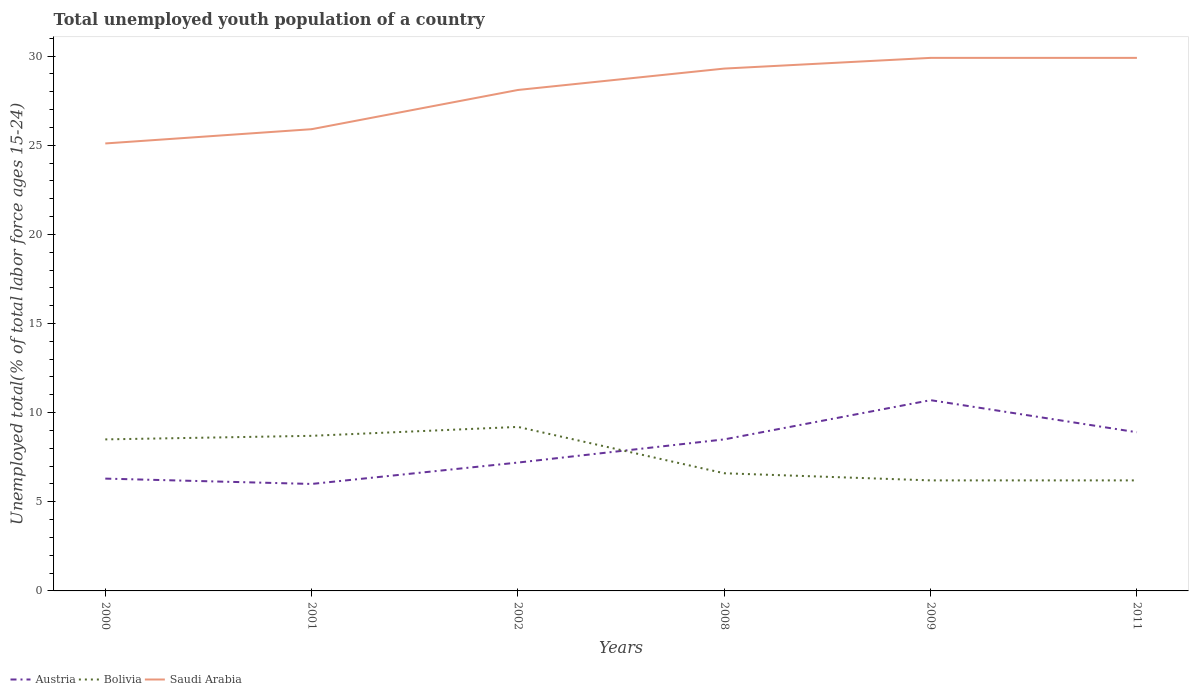Is the number of lines equal to the number of legend labels?
Your answer should be compact. Yes. What is the total percentage of total unemployed youth population of a country in Austria in the graph?
Your answer should be compact. -0.4. What is the difference between the highest and the second highest percentage of total unemployed youth population of a country in Bolivia?
Give a very brief answer. 3. Is the percentage of total unemployed youth population of a country in Bolivia strictly greater than the percentage of total unemployed youth population of a country in Austria over the years?
Provide a succinct answer. No. How many lines are there?
Offer a very short reply. 3. How many years are there in the graph?
Offer a very short reply. 6. What is the title of the graph?
Offer a terse response. Total unemployed youth population of a country. Does "Sao Tome and Principe" appear as one of the legend labels in the graph?
Your answer should be compact. No. What is the label or title of the Y-axis?
Offer a very short reply. Unemployed total(% of total labor force ages 15-24). What is the Unemployed total(% of total labor force ages 15-24) in Austria in 2000?
Offer a very short reply. 6.3. What is the Unemployed total(% of total labor force ages 15-24) of Saudi Arabia in 2000?
Give a very brief answer. 25.1. What is the Unemployed total(% of total labor force ages 15-24) of Austria in 2001?
Your answer should be very brief. 6. What is the Unemployed total(% of total labor force ages 15-24) of Bolivia in 2001?
Keep it short and to the point. 8.7. What is the Unemployed total(% of total labor force ages 15-24) in Saudi Arabia in 2001?
Make the answer very short. 25.9. What is the Unemployed total(% of total labor force ages 15-24) of Austria in 2002?
Keep it short and to the point. 7.2. What is the Unemployed total(% of total labor force ages 15-24) of Bolivia in 2002?
Make the answer very short. 9.2. What is the Unemployed total(% of total labor force ages 15-24) in Saudi Arabia in 2002?
Ensure brevity in your answer.  28.1. What is the Unemployed total(% of total labor force ages 15-24) in Bolivia in 2008?
Provide a short and direct response. 6.6. What is the Unemployed total(% of total labor force ages 15-24) of Saudi Arabia in 2008?
Ensure brevity in your answer.  29.3. What is the Unemployed total(% of total labor force ages 15-24) in Austria in 2009?
Your response must be concise. 10.7. What is the Unemployed total(% of total labor force ages 15-24) in Bolivia in 2009?
Provide a short and direct response. 6.2. What is the Unemployed total(% of total labor force ages 15-24) in Saudi Arabia in 2009?
Your answer should be compact. 29.9. What is the Unemployed total(% of total labor force ages 15-24) in Austria in 2011?
Offer a very short reply. 8.9. What is the Unemployed total(% of total labor force ages 15-24) of Bolivia in 2011?
Offer a very short reply. 6.2. What is the Unemployed total(% of total labor force ages 15-24) of Saudi Arabia in 2011?
Your answer should be compact. 29.9. Across all years, what is the maximum Unemployed total(% of total labor force ages 15-24) of Austria?
Make the answer very short. 10.7. Across all years, what is the maximum Unemployed total(% of total labor force ages 15-24) of Bolivia?
Your answer should be very brief. 9.2. Across all years, what is the maximum Unemployed total(% of total labor force ages 15-24) of Saudi Arabia?
Offer a terse response. 29.9. Across all years, what is the minimum Unemployed total(% of total labor force ages 15-24) of Austria?
Provide a succinct answer. 6. Across all years, what is the minimum Unemployed total(% of total labor force ages 15-24) in Bolivia?
Provide a succinct answer. 6.2. Across all years, what is the minimum Unemployed total(% of total labor force ages 15-24) of Saudi Arabia?
Your answer should be very brief. 25.1. What is the total Unemployed total(% of total labor force ages 15-24) of Austria in the graph?
Provide a short and direct response. 47.6. What is the total Unemployed total(% of total labor force ages 15-24) of Bolivia in the graph?
Offer a very short reply. 45.4. What is the total Unemployed total(% of total labor force ages 15-24) of Saudi Arabia in the graph?
Your answer should be very brief. 168.2. What is the difference between the Unemployed total(% of total labor force ages 15-24) in Austria in 2000 and that in 2001?
Keep it short and to the point. 0.3. What is the difference between the Unemployed total(% of total labor force ages 15-24) of Saudi Arabia in 2000 and that in 2001?
Provide a succinct answer. -0.8. What is the difference between the Unemployed total(% of total labor force ages 15-24) of Bolivia in 2000 and that in 2002?
Offer a terse response. -0.7. What is the difference between the Unemployed total(% of total labor force ages 15-24) of Austria in 2000 and that in 2008?
Your response must be concise. -2.2. What is the difference between the Unemployed total(% of total labor force ages 15-24) of Bolivia in 2000 and that in 2009?
Your response must be concise. 2.3. What is the difference between the Unemployed total(% of total labor force ages 15-24) in Austria in 2000 and that in 2011?
Provide a short and direct response. -2.6. What is the difference between the Unemployed total(% of total labor force ages 15-24) of Bolivia in 2000 and that in 2011?
Provide a short and direct response. 2.3. What is the difference between the Unemployed total(% of total labor force ages 15-24) in Bolivia in 2001 and that in 2002?
Offer a terse response. -0.5. What is the difference between the Unemployed total(% of total labor force ages 15-24) in Saudi Arabia in 2001 and that in 2002?
Offer a terse response. -2.2. What is the difference between the Unemployed total(% of total labor force ages 15-24) in Austria in 2001 and that in 2009?
Make the answer very short. -4.7. What is the difference between the Unemployed total(% of total labor force ages 15-24) of Bolivia in 2001 and that in 2009?
Offer a terse response. 2.5. What is the difference between the Unemployed total(% of total labor force ages 15-24) in Bolivia in 2001 and that in 2011?
Provide a short and direct response. 2.5. What is the difference between the Unemployed total(% of total labor force ages 15-24) of Saudi Arabia in 2001 and that in 2011?
Provide a succinct answer. -4. What is the difference between the Unemployed total(% of total labor force ages 15-24) of Austria in 2002 and that in 2008?
Provide a short and direct response. -1.3. What is the difference between the Unemployed total(% of total labor force ages 15-24) in Bolivia in 2002 and that in 2008?
Provide a succinct answer. 2.6. What is the difference between the Unemployed total(% of total labor force ages 15-24) in Austria in 2002 and that in 2009?
Ensure brevity in your answer.  -3.5. What is the difference between the Unemployed total(% of total labor force ages 15-24) in Saudi Arabia in 2002 and that in 2009?
Your answer should be very brief. -1.8. What is the difference between the Unemployed total(% of total labor force ages 15-24) of Austria in 2002 and that in 2011?
Give a very brief answer. -1.7. What is the difference between the Unemployed total(% of total labor force ages 15-24) in Austria in 2008 and that in 2009?
Offer a terse response. -2.2. What is the difference between the Unemployed total(% of total labor force ages 15-24) in Austria in 2008 and that in 2011?
Your response must be concise. -0.4. What is the difference between the Unemployed total(% of total labor force ages 15-24) in Saudi Arabia in 2008 and that in 2011?
Offer a very short reply. -0.6. What is the difference between the Unemployed total(% of total labor force ages 15-24) in Austria in 2009 and that in 2011?
Offer a very short reply. 1.8. What is the difference between the Unemployed total(% of total labor force ages 15-24) of Austria in 2000 and the Unemployed total(% of total labor force ages 15-24) of Saudi Arabia in 2001?
Offer a very short reply. -19.6. What is the difference between the Unemployed total(% of total labor force ages 15-24) of Bolivia in 2000 and the Unemployed total(% of total labor force ages 15-24) of Saudi Arabia in 2001?
Make the answer very short. -17.4. What is the difference between the Unemployed total(% of total labor force ages 15-24) of Austria in 2000 and the Unemployed total(% of total labor force ages 15-24) of Bolivia in 2002?
Ensure brevity in your answer.  -2.9. What is the difference between the Unemployed total(% of total labor force ages 15-24) in Austria in 2000 and the Unemployed total(% of total labor force ages 15-24) in Saudi Arabia in 2002?
Your answer should be compact. -21.8. What is the difference between the Unemployed total(% of total labor force ages 15-24) of Bolivia in 2000 and the Unemployed total(% of total labor force ages 15-24) of Saudi Arabia in 2002?
Provide a short and direct response. -19.6. What is the difference between the Unemployed total(% of total labor force ages 15-24) of Austria in 2000 and the Unemployed total(% of total labor force ages 15-24) of Saudi Arabia in 2008?
Offer a very short reply. -23. What is the difference between the Unemployed total(% of total labor force ages 15-24) of Bolivia in 2000 and the Unemployed total(% of total labor force ages 15-24) of Saudi Arabia in 2008?
Your answer should be compact. -20.8. What is the difference between the Unemployed total(% of total labor force ages 15-24) in Austria in 2000 and the Unemployed total(% of total labor force ages 15-24) in Saudi Arabia in 2009?
Your answer should be compact. -23.6. What is the difference between the Unemployed total(% of total labor force ages 15-24) of Bolivia in 2000 and the Unemployed total(% of total labor force ages 15-24) of Saudi Arabia in 2009?
Give a very brief answer. -21.4. What is the difference between the Unemployed total(% of total labor force ages 15-24) in Austria in 2000 and the Unemployed total(% of total labor force ages 15-24) in Bolivia in 2011?
Make the answer very short. 0.1. What is the difference between the Unemployed total(% of total labor force ages 15-24) in Austria in 2000 and the Unemployed total(% of total labor force ages 15-24) in Saudi Arabia in 2011?
Your response must be concise. -23.6. What is the difference between the Unemployed total(% of total labor force ages 15-24) in Bolivia in 2000 and the Unemployed total(% of total labor force ages 15-24) in Saudi Arabia in 2011?
Ensure brevity in your answer.  -21.4. What is the difference between the Unemployed total(% of total labor force ages 15-24) in Austria in 2001 and the Unemployed total(% of total labor force ages 15-24) in Saudi Arabia in 2002?
Ensure brevity in your answer.  -22.1. What is the difference between the Unemployed total(% of total labor force ages 15-24) of Bolivia in 2001 and the Unemployed total(% of total labor force ages 15-24) of Saudi Arabia in 2002?
Keep it short and to the point. -19.4. What is the difference between the Unemployed total(% of total labor force ages 15-24) of Austria in 2001 and the Unemployed total(% of total labor force ages 15-24) of Saudi Arabia in 2008?
Ensure brevity in your answer.  -23.3. What is the difference between the Unemployed total(% of total labor force ages 15-24) in Bolivia in 2001 and the Unemployed total(% of total labor force ages 15-24) in Saudi Arabia in 2008?
Your answer should be compact. -20.6. What is the difference between the Unemployed total(% of total labor force ages 15-24) of Austria in 2001 and the Unemployed total(% of total labor force ages 15-24) of Bolivia in 2009?
Give a very brief answer. -0.2. What is the difference between the Unemployed total(% of total labor force ages 15-24) of Austria in 2001 and the Unemployed total(% of total labor force ages 15-24) of Saudi Arabia in 2009?
Give a very brief answer. -23.9. What is the difference between the Unemployed total(% of total labor force ages 15-24) of Bolivia in 2001 and the Unemployed total(% of total labor force ages 15-24) of Saudi Arabia in 2009?
Keep it short and to the point. -21.2. What is the difference between the Unemployed total(% of total labor force ages 15-24) of Austria in 2001 and the Unemployed total(% of total labor force ages 15-24) of Bolivia in 2011?
Keep it short and to the point. -0.2. What is the difference between the Unemployed total(% of total labor force ages 15-24) of Austria in 2001 and the Unemployed total(% of total labor force ages 15-24) of Saudi Arabia in 2011?
Provide a short and direct response. -23.9. What is the difference between the Unemployed total(% of total labor force ages 15-24) in Bolivia in 2001 and the Unemployed total(% of total labor force ages 15-24) in Saudi Arabia in 2011?
Make the answer very short. -21.2. What is the difference between the Unemployed total(% of total labor force ages 15-24) of Austria in 2002 and the Unemployed total(% of total labor force ages 15-24) of Bolivia in 2008?
Give a very brief answer. 0.6. What is the difference between the Unemployed total(% of total labor force ages 15-24) of Austria in 2002 and the Unemployed total(% of total labor force ages 15-24) of Saudi Arabia in 2008?
Keep it short and to the point. -22.1. What is the difference between the Unemployed total(% of total labor force ages 15-24) of Bolivia in 2002 and the Unemployed total(% of total labor force ages 15-24) of Saudi Arabia in 2008?
Offer a very short reply. -20.1. What is the difference between the Unemployed total(% of total labor force ages 15-24) of Austria in 2002 and the Unemployed total(% of total labor force ages 15-24) of Bolivia in 2009?
Keep it short and to the point. 1. What is the difference between the Unemployed total(% of total labor force ages 15-24) of Austria in 2002 and the Unemployed total(% of total labor force ages 15-24) of Saudi Arabia in 2009?
Offer a very short reply. -22.7. What is the difference between the Unemployed total(% of total labor force ages 15-24) of Bolivia in 2002 and the Unemployed total(% of total labor force ages 15-24) of Saudi Arabia in 2009?
Make the answer very short. -20.7. What is the difference between the Unemployed total(% of total labor force ages 15-24) of Austria in 2002 and the Unemployed total(% of total labor force ages 15-24) of Saudi Arabia in 2011?
Your answer should be very brief. -22.7. What is the difference between the Unemployed total(% of total labor force ages 15-24) of Bolivia in 2002 and the Unemployed total(% of total labor force ages 15-24) of Saudi Arabia in 2011?
Ensure brevity in your answer.  -20.7. What is the difference between the Unemployed total(% of total labor force ages 15-24) of Austria in 2008 and the Unemployed total(% of total labor force ages 15-24) of Saudi Arabia in 2009?
Give a very brief answer. -21.4. What is the difference between the Unemployed total(% of total labor force ages 15-24) in Bolivia in 2008 and the Unemployed total(% of total labor force ages 15-24) in Saudi Arabia in 2009?
Offer a very short reply. -23.3. What is the difference between the Unemployed total(% of total labor force ages 15-24) of Austria in 2008 and the Unemployed total(% of total labor force ages 15-24) of Saudi Arabia in 2011?
Your response must be concise. -21.4. What is the difference between the Unemployed total(% of total labor force ages 15-24) in Bolivia in 2008 and the Unemployed total(% of total labor force ages 15-24) in Saudi Arabia in 2011?
Provide a short and direct response. -23.3. What is the difference between the Unemployed total(% of total labor force ages 15-24) in Austria in 2009 and the Unemployed total(% of total labor force ages 15-24) in Bolivia in 2011?
Your response must be concise. 4.5. What is the difference between the Unemployed total(% of total labor force ages 15-24) in Austria in 2009 and the Unemployed total(% of total labor force ages 15-24) in Saudi Arabia in 2011?
Your answer should be very brief. -19.2. What is the difference between the Unemployed total(% of total labor force ages 15-24) in Bolivia in 2009 and the Unemployed total(% of total labor force ages 15-24) in Saudi Arabia in 2011?
Offer a terse response. -23.7. What is the average Unemployed total(% of total labor force ages 15-24) in Austria per year?
Your answer should be compact. 7.93. What is the average Unemployed total(% of total labor force ages 15-24) in Bolivia per year?
Give a very brief answer. 7.57. What is the average Unemployed total(% of total labor force ages 15-24) in Saudi Arabia per year?
Provide a succinct answer. 28.03. In the year 2000, what is the difference between the Unemployed total(% of total labor force ages 15-24) of Austria and Unemployed total(% of total labor force ages 15-24) of Saudi Arabia?
Keep it short and to the point. -18.8. In the year 2000, what is the difference between the Unemployed total(% of total labor force ages 15-24) of Bolivia and Unemployed total(% of total labor force ages 15-24) of Saudi Arabia?
Give a very brief answer. -16.6. In the year 2001, what is the difference between the Unemployed total(% of total labor force ages 15-24) in Austria and Unemployed total(% of total labor force ages 15-24) in Bolivia?
Offer a very short reply. -2.7. In the year 2001, what is the difference between the Unemployed total(% of total labor force ages 15-24) of Austria and Unemployed total(% of total labor force ages 15-24) of Saudi Arabia?
Your answer should be very brief. -19.9. In the year 2001, what is the difference between the Unemployed total(% of total labor force ages 15-24) in Bolivia and Unemployed total(% of total labor force ages 15-24) in Saudi Arabia?
Make the answer very short. -17.2. In the year 2002, what is the difference between the Unemployed total(% of total labor force ages 15-24) of Austria and Unemployed total(% of total labor force ages 15-24) of Saudi Arabia?
Your response must be concise. -20.9. In the year 2002, what is the difference between the Unemployed total(% of total labor force ages 15-24) in Bolivia and Unemployed total(% of total labor force ages 15-24) in Saudi Arabia?
Offer a terse response. -18.9. In the year 2008, what is the difference between the Unemployed total(% of total labor force ages 15-24) in Austria and Unemployed total(% of total labor force ages 15-24) in Bolivia?
Provide a short and direct response. 1.9. In the year 2008, what is the difference between the Unemployed total(% of total labor force ages 15-24) of Austria and Unemployed total(% of total labor force ages 15-24) of Saudi Arabia?
Ensure brevity in your answer.  -20.8. In the year 2008, what is the difference between the Unemployed total(% of total labor force ages 15-24) of Bolivia and Unemployed total(% of total labor force ages 15-24) of Saudi Arabia?
Offer a very short reply. -22.7. In the year 2009, what is the difference between the Unemployed total(% of total labor force ages 15-24) in Austria and Unemployed total(% of total labor force ages 15-24) in Saudi Arabia?
Keep it short and to the point. -19.2. In the year 2009, what is the difference between the Unemployed total(% of total labor force ages 15-24) in Bolivia and Unemployed total(% of total labor force ages 15-24) in Saudi Arabia?
Offer a very short reply. -23.7. In the year 2011, what is the difference between the Unemployed total(% of total labor force ages 15-24) of Austria and Unemployed total(% of total labor force ages 15-24) of Saudi Arabia?
Provide a succinct answer. -21. In the year 2011, what is the difference between the Unemployed total(% of total labor force ages 15-24) in Bolivia and Unemployed total(% of total labor force ages 15-24) in Saudi Arabia?
Offer a terse response. -23.7. What is the ratio of the Unemployed total(% of total labor force ages 15-24) of Saudi Arabia in 2000 to that in 2001?
Offer a very short reply. 0.97. What is the ratio of the Unemployed total(% of total labor force ages 15-24) of Austria in 2000 to that in 2002?
Offer a terse response. 0.88. What is the ratio of the Unemployed total(% of total labor force ages 15-24) of Bolivia in 2000 to that in 2002?
Offer a terse response. 0.92. What is the ratio of the Unemployed total(% of total labor force ages 15-24) of Saudi Arabia in 2000 to that in 2002?
Your answer should be compact. 0.89. What is the ratio of the Unemployed total(% of total labor force ages 15-24) of Austria in 2000 to that in 2008?
Give a very brief answer. 0.74. What is the ratio of the Unemployed total(% of total labor force ages 15-24) of Bolivia in 2000 to that in 2008?
Make the answer very short. 1.29. What is the ratio of the Unemployed total(% of total labor force ages 15-24) of Saudi Arabia in 2000 to that in 2008?
Offer a terse response. 0.86. What is the ratio of the Unemployed total(% of total labor force ages 15-24) in Austria in 2000 to that in 2009?
Offer a very short reply. 0.59. What is the ratio of the Unemployed total(% of total labor force ages 15-24) of Bolivia in 2000 to that in 2009?
Your response must be concise. 1.37. What is the ratio of the Unemployed total(% of total labor force ages 15-24) of Saudi Arabia in 2000 to that in 2009?
Your response must be concise. 0.84. What is the ratio of the Unemployed total(% of total labor force ages 15-24) of Austria in 2000 to that in 2011?
Keep it short and to the point. 0.71. What is the ratio of the Unemployed total(% of total labor force ages 15-24) of Bolivia in 2000 to that in 2011?
Give a very brief answer. 1.37. What is the ratio of the Unemployed total(% of total labor force ages 15-24) of Saudi Arabia in 2000 to that in 2011?
Make the answer very short. 0.84. What is the ratio of the Unemployed total(% of total labor force ages 15-24) in Bolivia in 2001 to that in 2002?
Offer a terse response. 0.95. What is the ratio of the Unemployed total(% of total labor force ages 15-24) of Saudi Arabia in 2001 to that in 2002?
Give a very brief answer. 0.92. What is the ratio of the Unemployed total(% of total labor force ages 15-24) of Austria in 2001 to that in 2008?
Offer a very short reply. 0.71. What is the ratio of the Unemployed total(% of total labor force ages 15-24) in Bolivia in 2001 to that in 2008?
Ensure brevity in your answer.  1.32. What is the ratio of the Unemployed total(% of total labor force ages 15-24) in Saudi Arabia in 2001 to that in 2008?
Keep it short and to the point. 0.88. What is the ratio of the Unemployed total(% of total labor force ages 15-24) of Austria in 2001 to that in 2009?
Your response must be concise. 0.56. What is the ratio of the Unemployed total(% of total labor force ages 15-24) of Bolivia in 2001 to that in 2009?
Keep it short and to the point. 1.4. What is the ratio of the Unemployed total(% of total labor force ages 15-24) of Saudi Arabia in 2001 to that in 2009?
Your response must be concise. 0.87. What is the ratio of the Unemployed total(% of total labor force ages 15-24) of Austria in 2001 to that in 2011?
Offer a very short reply. 0.67. What is the ratio of the Unemployed total(% of total labor force ages 15-24) of Bolivia in 2001 to that in 2011?
Make the answer very short. 1.4. What is the ratio of the Unemployed total(% of total labor force ages 15-24) of Saudi Arabia in 2001 to that in 2011?
Ensure brevity in your answer.  0.87. What is the ratio of the Unemployed total(% of total labor force ages 15-24) of Austria in 2002 to that in 2008?
Provide a short and direct response. 0.85. What is the ratio of the Unemployed total(% of total labor force ages 15-24) of Bolivia in 2002 to that in 2008?
Make the answer very short. 1.39. What is the ratio of the Unemployed total(% of total labor force ages 15-24) in Saudi Arabia in 2002 to that in 2008?
Your response must be concise. 0.96. What is the ratio of the Unemployed total(% of total labor force ages 15-24) in Austria in 2002 to that in 2009?
Make the answer very short. 0.67. What is the ratio of the Unemployed total(% of total labor force ages 15-24) in Bolivia in 2002 to that in 2009?
Keep it short and to the point. 1.48. What is the ratio of the Unemployed total(% of total labor force ages 15-24) of Saudi Arabia in 2002 to that in 2009?
Your answer should be very brief. 0.94. What is the ratio of the Unemployed total(% of total labor force ages 15-24) in Austria in 2002 to that in 2011?
Your response must be concise. 0.81. What is the ratio of the Unemployed total(% of total labor force ages 15-24) in Bolivia in 2002 to that in 2011?
Keep it short and to the point. 1.48. What is the ratio of the Unemployed total(% of total labor force ages 15-24) in Saudi Arabia in 2002 to that in 2011?
Give a very brief answer. 0.94. What is the ratio of the Unemployed total(% of total labor force ages 15-24) in Austria in 2008 to that in 2009?
Ensure brevity in your answer.  0.79. What is the ratio of the Unemployed total(% of total labor force ages 15-24) of Bolivia in 2008 to that in 2009?
Your answer should be compact. 1.06. What is the ratio of the Unemployed total(% of total labor force ages 15-24) of Saudi Arabia in 2008 to that in 2009?
Keep it short and to the point. 0.98. What is the ratio of the Unemployed total(% of total labor force ages 15-24) of Austria in 2008 to that in 2011?
Your answer should be compact. 0.96. What is the ratio of the Unemployed total(% of total labor force ages 15-24) in Bolivia in 2008 to that in 2011?
Make the answer very short. 1.06. What is the ratio of the Unemployed total(% of total labor force ages 15-24) of Saudi Arabia in 2008 to that in 2011?
Keep it short and to the point. 0.98. What is the ratio of the Unemployed total(% of total labor force ages 15-24) of Austria in 2009 to that in 2011?
Your response must be concise. 1.2. What is the ratio of the Unemployed total(% of total labor force ages 15-24) of Bolivia in 2009 to that in 2011?
Provide a succinct answer. 1. What is the ratio of the Unemployed total(% of total labor force ages 15-24) of Saudi Arabia in 2009 to that in 2011?
Give a very brief answer. 1. What is the difference between the highest and the second highest Unemployed total(% of total labor force ages 15-24) of Bolivia?
Ensure brevity in your answer.  0.5. What is the difference between the highest and the second highest Unemployed total(% of total labor force ages 15-24) in Saudi Arabia?
Your response must be concise. 0. What is the difference between the highest and the lowest Unemployed total(% of total labor force ages 15-24) in Saudi Arabia?
Provide a succinct answer. 4.8. 